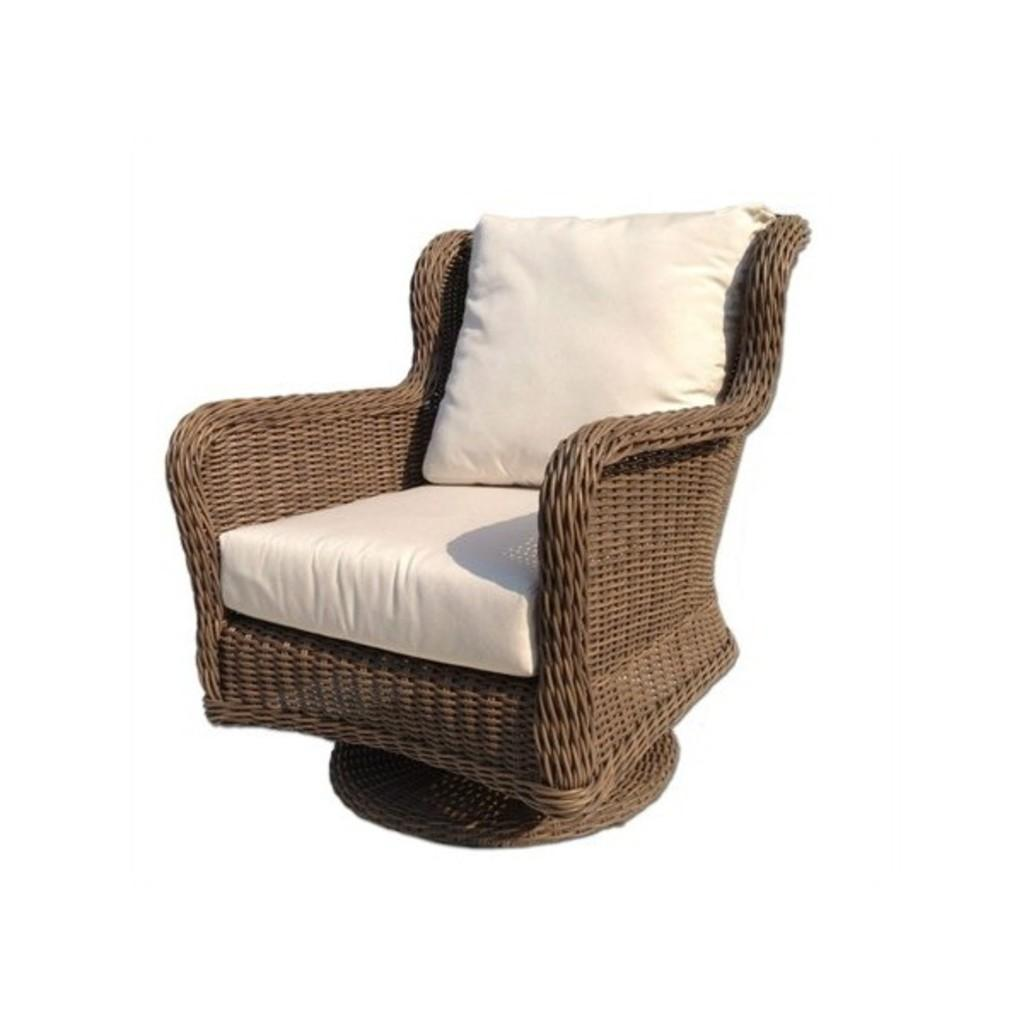What type of furniture is present in the image? There is a chair in the image. What is the color or design of the cushions on the chair? The chair has white cushions. Is the person in the image saying good-bye to the chair? There is no person present in the image, so it is not possible to determine if they are saying good-bye to the chair. 